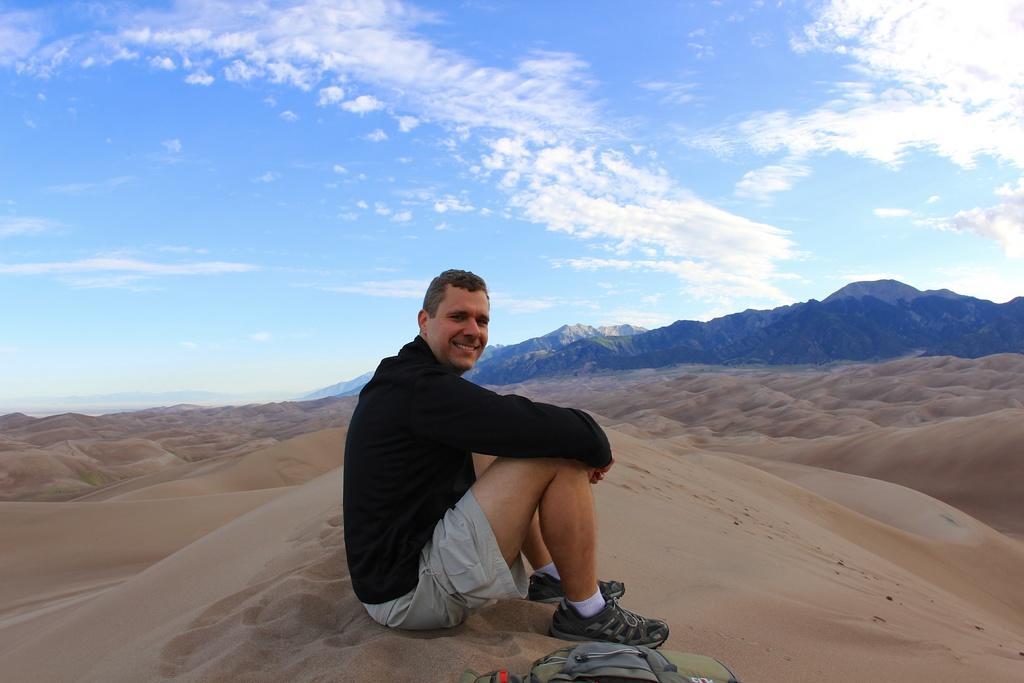In one or two sentences, can you explain what this image depicts? In this image there is a person sitting on the sand with a smile on his face, beside the person there is a bag, in the background of the image there are mountains, at the top of the image there are clouds in the sky. 